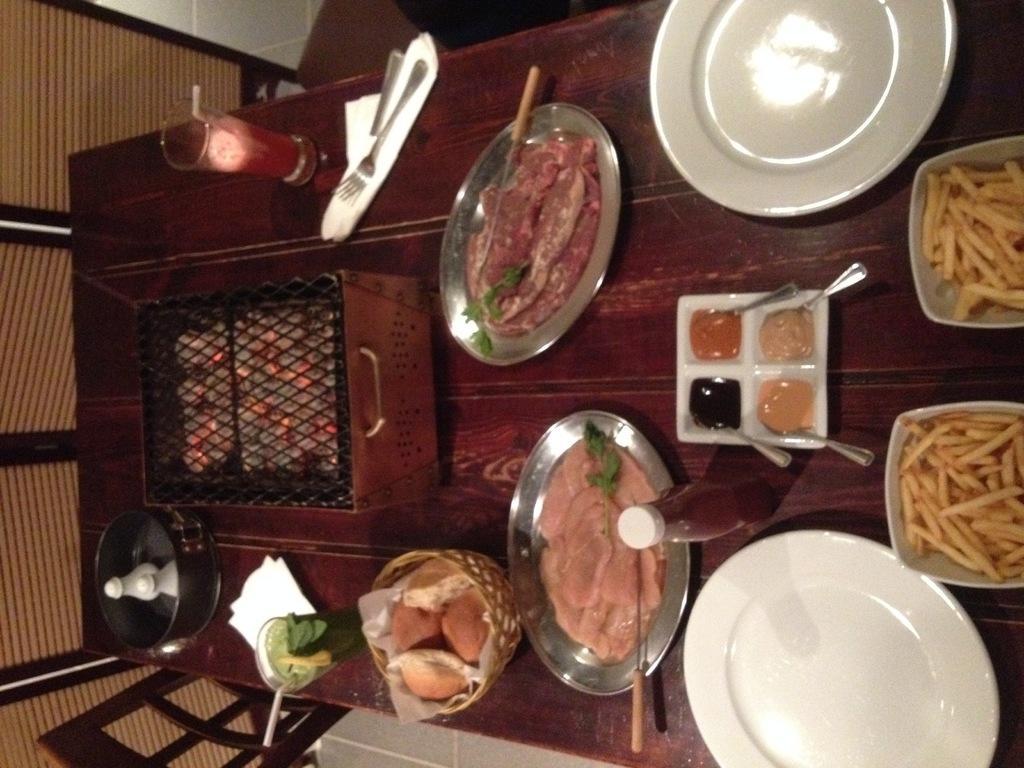Please provide a concise description of this image. In this image we can able to see few food items on the table, there is a heater on it, we can see two glasses, forks, four spoons, sauce bottle,and plates on the table. 